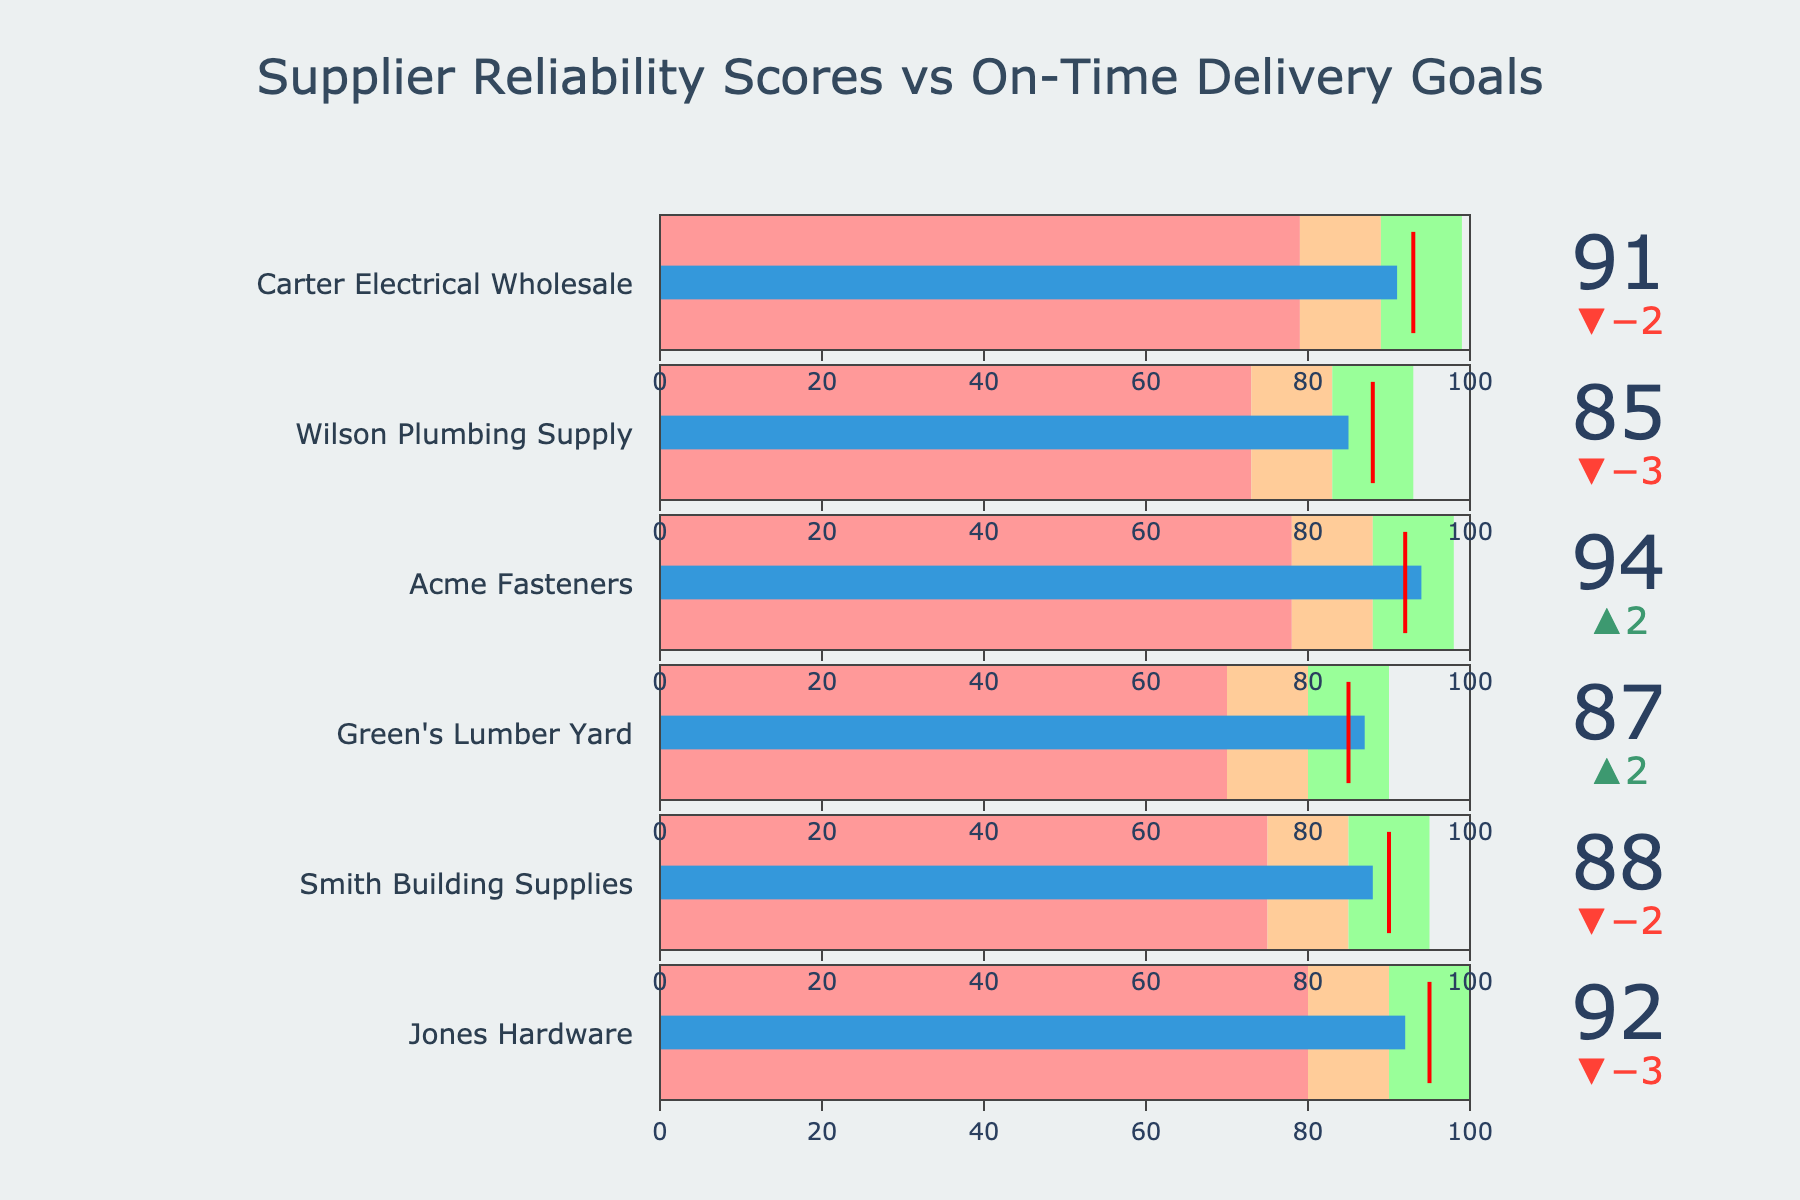How many suppliers are displayed in the figure? The figure contains one indicator for each supplier listed in the data. By counting the number of bullet indicators or the titles for each supplier, you can determine the total number of suppliers.
Answer: 6 What is the title of the figure? The title of the figure is located at the top of the chart and is usually set in a larger and bolder font to distinguish it from other text elements.
Answer: Supplier Reliability Scores vs On-Time Delivery Goals Which supplier has the lowest actual reliability score? By examining the values of the actual scores for each supplier, you can identify which one is the smallest. The actual scores are displayed within the indicators on the bullet chart for each supplier.
Answer: Wilson Plumbing Supply Which supplier exceeded their target by the largest margin? To find the largest margin of exceeding the target, calculate the difference between the actual and target scores for each supplier. The supplier with the most positive difference has exceeded their target by the largest amount.
Answer: Acme Fasteners What are the 'Poor', 'Satisfactory', and 'Good' benchmark ranges used in the chart? Each gauge in the bullet chart includes shaded ranges that represent 'Poor', 'Satisfactory', and 'Good' benchmark levels. The color indicators typically help to distinguish these ranges.
Answer: Poor: 70-80; Satisfactory: 80-90; Good: 90-100 Does any supplier fail to reach the 'Good' benchmark for reliability? The 'Good' benchmark ends at a score of 90. By checking if the actual scores of any suppliers fall below 90, you can determine if any fail to reach the 'Good' benchmark.
Answer: Yes, Wilson Plumbing Supply How does the reliability score of Green's Lumber Yard compare to its target? Identify the actual score and the target score for Green's Lumber Yard. The actual score is displayed and can be compared directly to the target score to see if it is higher, lower, or equal.
Answer: Higher by 2 What percentage of suppliers met or exceeded their reliability targets? Determine how many suppliers have actual scores equal to or higher than their targets. Then, divide this number by the total number of suppliers and multiply by 100 to get the percentage.
Answer: 66.67% Which supplier is closest to meeting their target without exceeding it? Calculate the difference between the actual score and the target score for each supplier who did not exceed their target. The supplier with the smallest non-negative difference is closest without exceeding.
Answer: Carter Electrical Wholesale What color represents the 'Good' performance range in the chart? In bullet charts, different performance ranges are usually indicated by different colors. The color for the 'Good' range can be identified by looking for the corresponding range indicator on the chart's legend or the gauge itself.
Answer: Green 